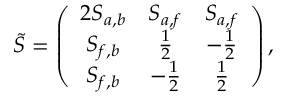<formula> <loc_0><loc_0><loc_500><loc_500>\widetilde { S } = \left ( \begin{array} { c c c } { { 2 S _ { a , b } } } & { { S _ { a , f } } } & { { S _ { a , f } } } \\ { { S _ { f , b } } } & { { \frac { 1 } { 2 } } } & { { - \frac { 1 } { 2 } } } \\ { { S _ { f , b } } } & { { - \frac { 1 } { 2 } } } & { { \frac { 1 } { 2 } } } \end{array} \right ) ,</formula> 